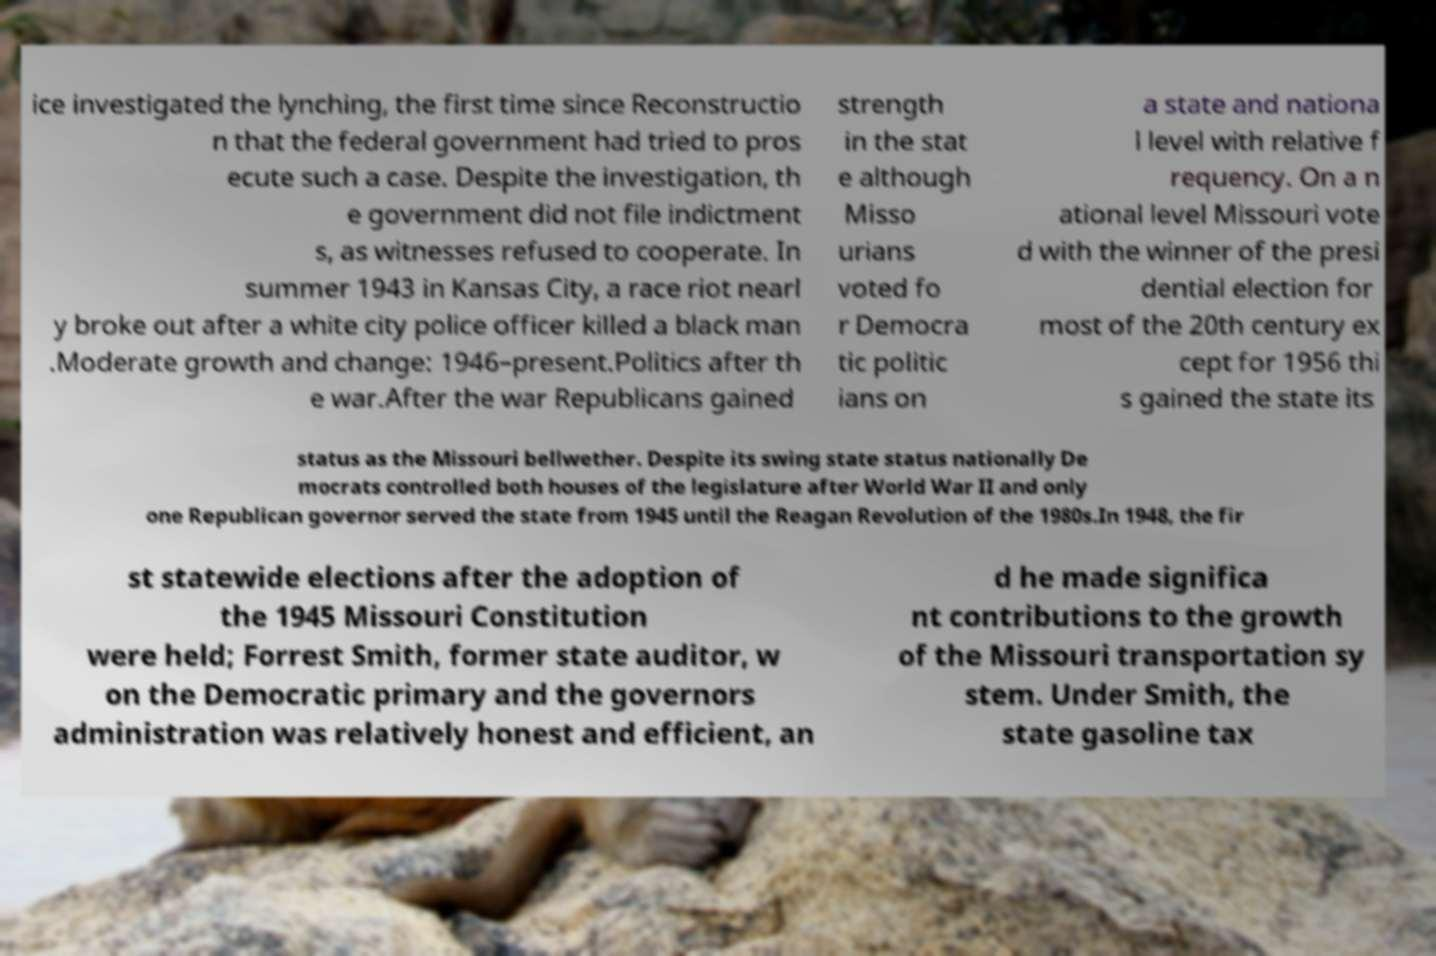Can you accurately transcribe the text from the provided image for me? ice investigated the lynching, the first time since Reconstructio n that the federal government had tried to pros ecute such a case. Despite the investigation, th e government did not file indictment s, as witnesses refused to cooperate. In summer 1943 in Kansas City, a race riot nearl y broke out after a white city police officer killed a black man .Moderate growth and change: 1946–present.Politics after th e war.After the war Republicans gained strength in the stat e although Misso urians voted fo r Democra tic politic ians on a state and nationa l level with relative f requency. On a n ational level Missouri vote d with the winner of the presi dential election for most of the 20th century ex cept for 1956 thi s gained the state its status as the Missouri bellwether. Despite its swing state status nationally De mocrats controlled both houses of the legislature after World War II and only one Republican governor served the state from 1945 until the Reagan Revolution of the 1980s.In 1948, the fir st statewide elections after the adoption of the 1945 Missouri Constitution were held; Forrest Smith, former state auditor, w on the Democratic primary and the governors administration was relatively honest and efficient, an d he made significa nt contributions to the growth of the Missouri transportation sy stem. Under Smith, the state gasoline tax 